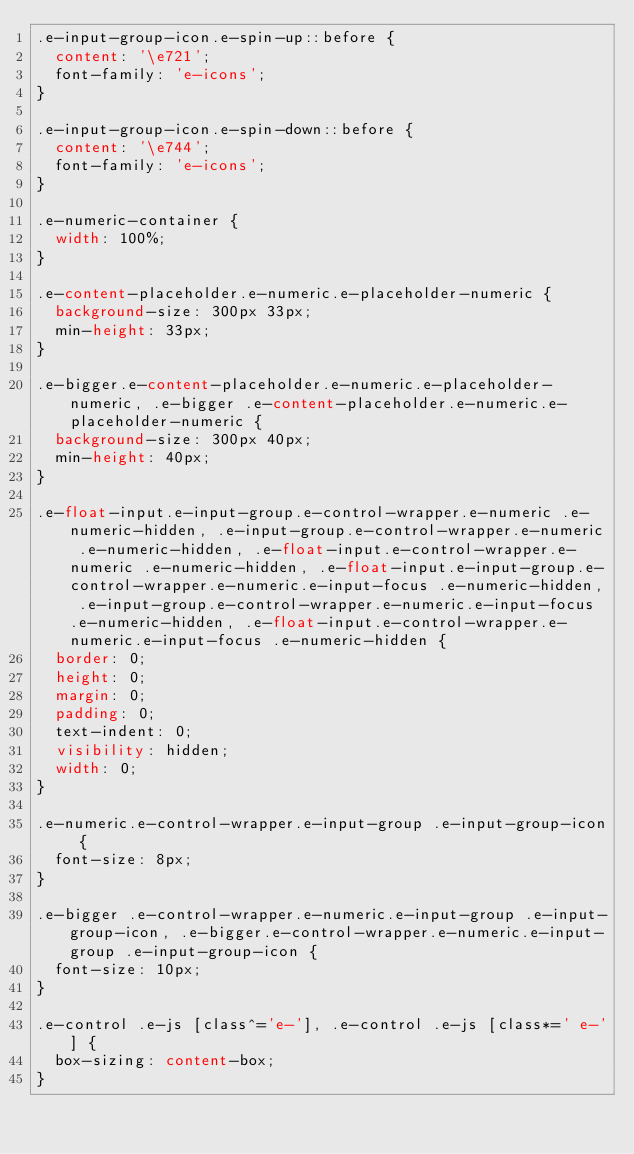<code> <loc_0><loc_0><loc_500><loc_500><_CSS_>.e-input-group-icon.e-spin-up::before {
  content: '\e721';
  font-family: 'e-icons';
}

.e-input-group-icon.e-spin-down::before {
  content: '\e744';
  font-family: 'e-icons';
}

.e-numeric-container {
  width: 100%;
}

.e-content-placeholder.e-numeric.e-placeholder-numeric {
  background-size: 300px 33px;
  min-height: 33px;
}

.e-bigger.e-content-placeholder.e-numeric.e-placeholder-numeric, .e-bigger .e-content-placeholder.e-numeric.e-placeholder-numeric {
  background-size: 300px 40px;
  min-height: 40px;
}

.e-float-input.e-input-group.e-control-wrapper.e-numeric .e-numeric-hidden, .e-input-group.e-control-wrapper.e-numeric .e-numeric-hidden, .e-float-input.e-control-wrapper.e-numeric .e-numeric-hidden, .e-float-input.e-input-group.e-control-wrapper.e-numeric.e-input-focus .e-numeric-hidden, .e-input-group.e-control-wrapper.e-numeric.e-input-focus .e-numeric-hidden, .e-float-input.e-control-wrapper.e-numeric.e-input-focus .e-numeric-hidden {
  border: 0;
  height: 0;
  margin: 0;
  padding: 0;
  text-indent: 0;
  visibility: hidden;
  width: 0;
}

.e-numeric.e-control-wrapper.e-input-group .e-input-group-icon {
  font-size: 8px;
}

.e-bigger .e-control-wrapper.e-numeric.e-input-group .e-input-group-icon, .e-bigger.e-control-wrapper.e-numeric.e-input-group .e-input-group-icon {
  font-size: 10px;
}

.e-control .e-js [class^='e-'], .e-control .e-js [class*=' e-'] {
  box-sizing: content-box;
}
</code> 